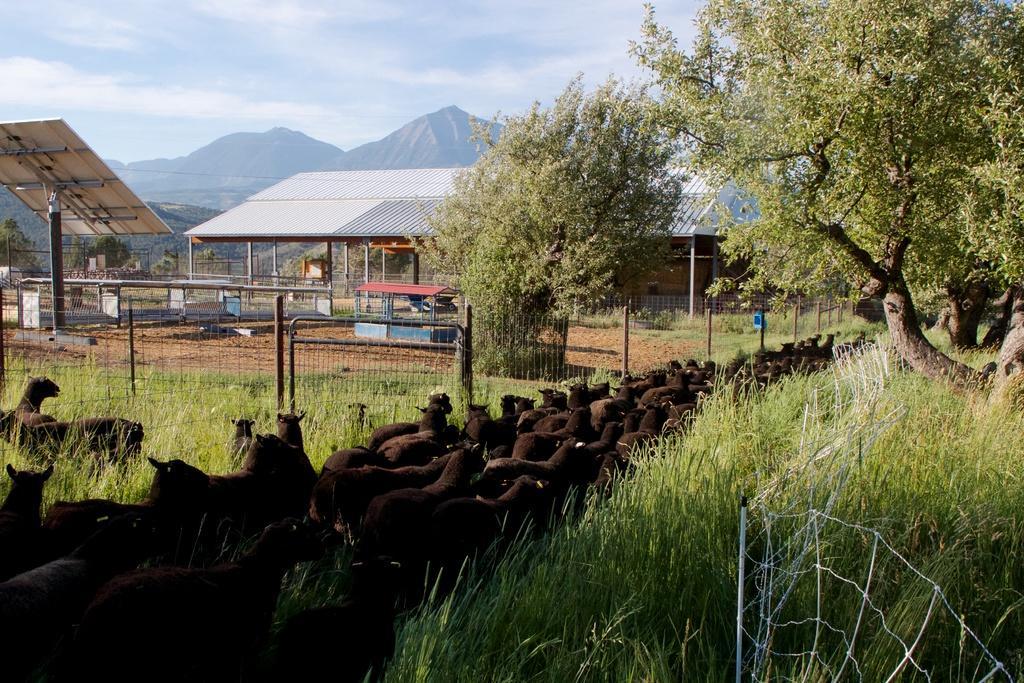Describe this image in one or two sentences. Sky is cloudy. This is an open shed. Here we can see animals, grass, fence and trees. Far there are mountains. A board with pole. 